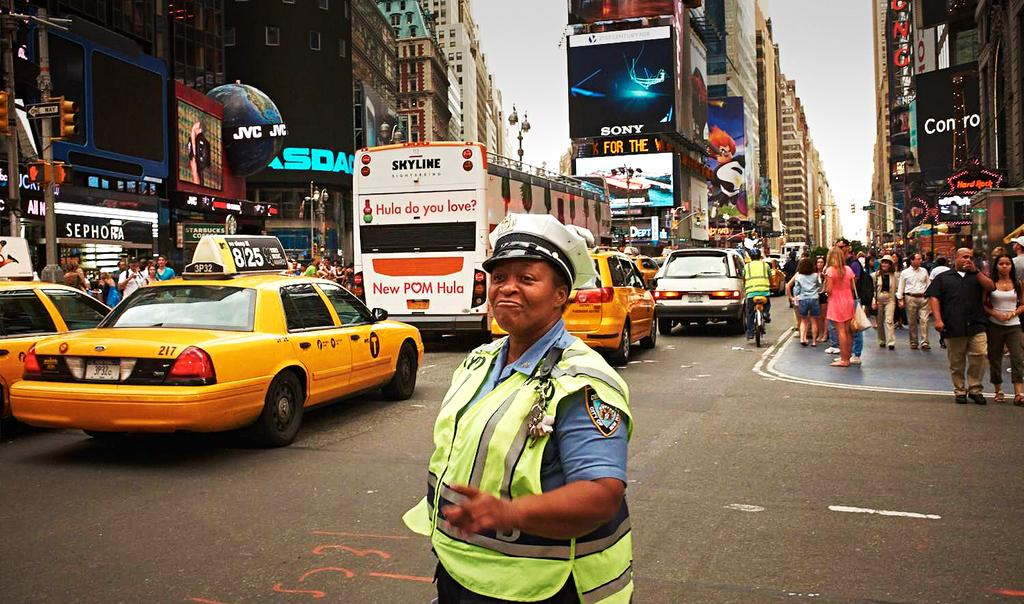<image>
Present a compact description of the photo's key features. The bus on a busy street has an advertisement on the back for the new POM Hula. 